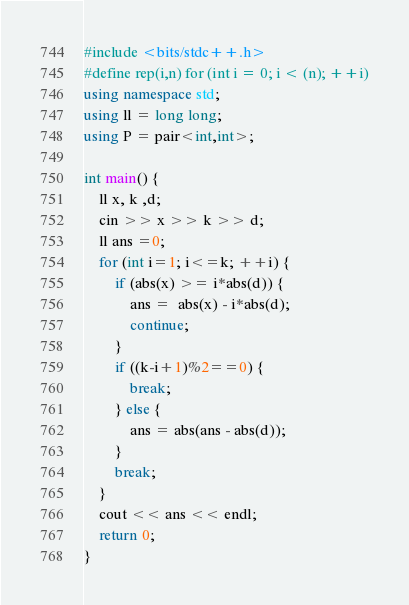<code> <loc_0><loc_0><loc_500><loc_500><_C++_>#include <bits/stdc++.h>
#define rep(i,n) for (int i = 0; i < (n); ++i)
using namespace std;
using ll = long long;
using P = pair<int,int>;

int main() {
    ll x, k ,d;
    cin >> x >> k >> d;
    ll ans =0;
    for (int i=1; i<=k; ++i) {
        if (abs(x) >= i*abs(d)) {
            ans =  abs(x) - i*abs(d);
            continue;
        }
        if ((k-i+1)%2==0) {
            break;
        } else {
            ans = abs(ans - abs(d));
        }
        break;
    }
    cout << ans << endl;
    return 0;
}</code> 